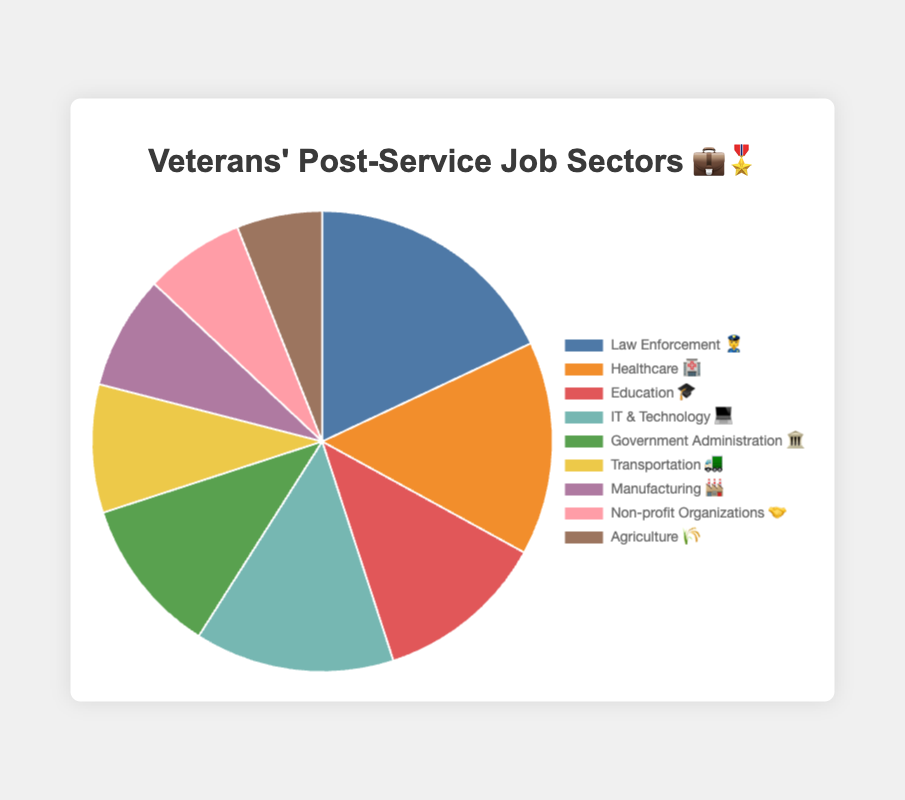Which job sector employs the highest percentage of veterans? The sector with the highest percentage is identified by looking for the largest slice in the pie chart.
Answer: Law Enforcement 👮 Which job sector has the smallest slice in the pie chart? The smallest slice represents the lowest percentage among all job sectors.
Answer: Agriculture 🌾 How do the percentages of veterans in Law Enforcement 👮 and Healthcare 🏥 compare? Law Enforcement employs 18% and Healthcare employs 15%, so Law Enforcement employs 3% more veterans than Healthcare.
Answer: Law Enforcement 👮 employs 3% more What is the sum of percentages of veterans in Education 🎓 and IT & Technology 💻? Adding the percentages for Education (12%) and IT & Technology (14%) gives 12% + 14% = 26%.
Answer: 26% What is the difference in percentage between Transportation 🚛 and Non-profit Organizations 🤝? Subtract the percentage for Non-profit Organizations (7%) from Transportation (9%) to find 9% - 7% = 2%.
Answer: 2% Rank the top three job sectors employing the most veterans? The top three percentages are 18% (Law Enforcement), 15% (Healthcare), and 14% (IT & Technology).
Answer: Law Enforcement 👮, Healthcare 🏥, IT & Technology 💻 Which job sectors employ fewer veterans than Government Administration 🏛️? Government Administration employs 11%; sectors with lower percentages are Transportation (9%), Manufacturing (8%), Non-profit Organizations (7%), and Agriculture (6%).
Answer: Transportation 🚛, Manufacturing 🏭, Non-profit Organizations 🤝, Agriculture 🌾 What is the total percentage of veterans employed in sectors outside of Law Enforcement 👮 and Healthcare 🏥? Subtracting the sum of Law Enforcement (18%) and Healthcare (15%) from 100% is 100% - (18% + 15%) = 67%.
Answer: 67% What is the combined percentage for the sectors with the lowest three employments? Adding the percentages for the lowest three sectors: Agriculture (6%), Non-profit Organizations (7%), and Manufacturing (8%) gives 6% + 7% + 8% = 21%.
Answer: 21% How does the employment in Manufacturing 🏭 compare to Agriculture 🌾 in terms of percentage? Manufacturing employs 8% and Agriculture employs 6%, so Manufacturing employs 2% more veterans than Agriculture.
Answer: Manufacturing 🏭 employs 2% more 